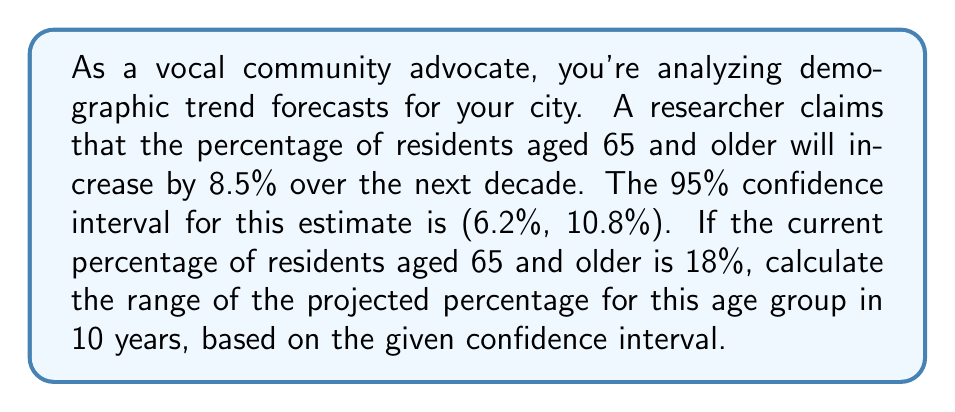Can you answer this question? Let's approach this step-by-step:

1) The current percentage of residents aged 65 and older is 18%.

2) The estimated increase is 8.5%, with a 95% confidence interval of (6.2%, 10.8%).

3) To find the range of the projected percentage, we need to add the lower and upper bounds of the confidence interval to the current percentage:

   Lower bound: $18\% + 6.2\% = 24.2\%$
   Upper bound: $18\% + 10.8\% = 28.8\%$

4) We can express this as an interval:

   $$(24.2\%, 28.8\%)$$

5) Interpretation: We are 95% confident that the true percentage of residents aged 65 and older in 10 years will fall between 24.2% and 28.8%.

This range provides valuable information for community planning, resource allocation, and policy-making decisions related to the aging population.
Answer: (24.2%, 28.8%) 